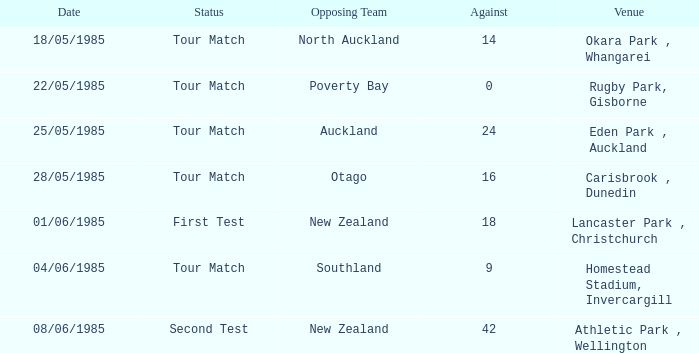Could you parse the entire table as a dict? {'header': ['Date', 'Status', 'Opposing Team', 'Against', 'Venue'], 'rows': [['18/05/1985', 'Tour Match', 'North Auckland', '14', 'Okara Park , Whangarei'], ['22/05/1985', 'Tour Match', 'Poverty Bay', '0', 'Rugby Park, Gisborne'], ['25/05/1985', 'Tour Match', 'Auckland', '24', 'Eden Park , Auckland'], ['28/05/1985', 'Tour Match', 'Otago', '16', 'Carisbrook , Dunedin'], ['01/06/1985', 'First Test', 'New Zealand', '18', 'Lancaster Park , Christchurch'], ['04/06/1985', 'Tour Match', 'Southland', '9', 'Homestead Stadium, Invercargill'], ['08/06/1985', 'Second Test', 'New Zealand', '42', 'Athletic Park , Wellington']]} Which opposing team had an Against score less than 42 and a Tour Match status in Rugby Park, Gisborne? Poverty Bay. 